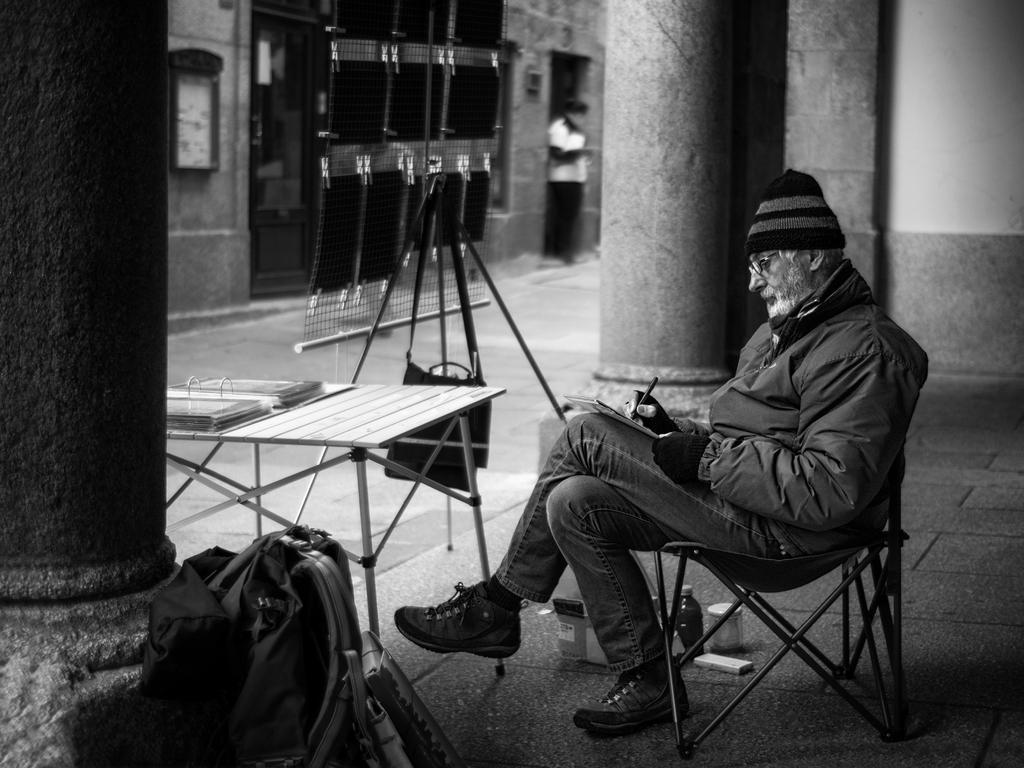In one or two sentences, can you explain what this image depicts? There is one man sitting on the chair and holding a pen as we can see on the right side of this image. There is a bag, table and a pillar on the left side of this image. We can see a wall clock, a person and a wall in the background. 